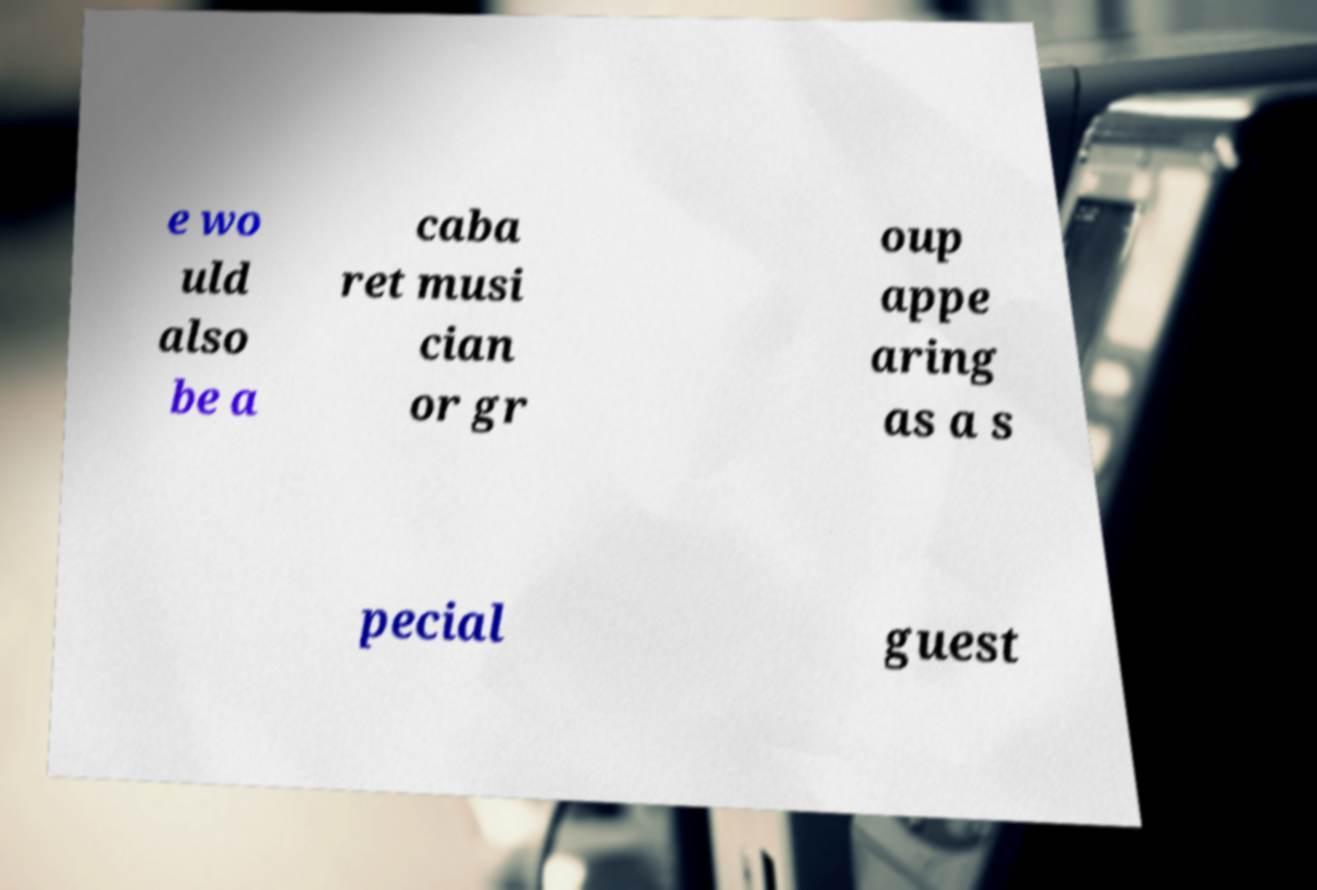I need the written content from this picture converted into text. Can you do that? e wo uld also be a caba ret musi cian or gr oup appe aring as a s pecial guest 